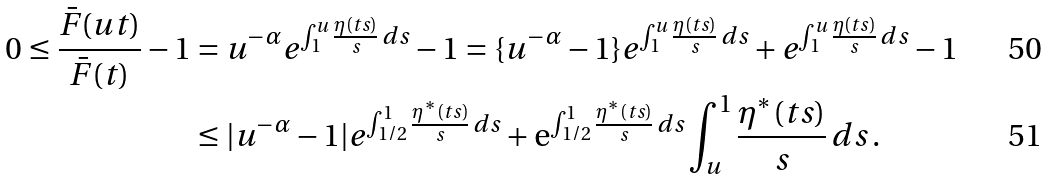Convert formula to latex. <formula><loc_0><loc_0><loc_500><loc_500>0 \leq \frac { \bar { F } ( u t ) } { \bar { F } ( t ) } - 1 & = u ^ { - \alpha } e ^ { \int _ { 1 } ^ { u } \frac { \eta ( t s ) } s \, d s } - 1 = \{ u ^ { - \alpha } - 1 \} e ^ { \int _ { 1 } ^ { u } \frac { \eta ( t s ) } s \, d s } + e ^ { \int _ { 1 } ^ { u } \frac { \eta ( t s ) } s \, d s } - 1 \\ & \leq | u ^ { - \alpha } - 1 | e ^ { \int _ { 1 / 2 } ^ { 1 } \frac { \eta ^ { * } ( t s ) } s \, d s } + \mathrm e ^ { \int _ { 1 / 2 } ^ { 1 } \frac { \eta ^ { * } ( t s ) } s \, d s } \int _ { u } ^ { 1 } \frac { \eta ^ { * } ( t s ) } s \, d s \, .</formula> 